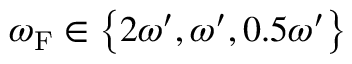Convert formula to latex. <formula><loc_0><loc_0><loc_500><loc_500>\omega _ { F } \in \left \{ 2 \omega ^ { \prime } , \omega ^ { \prime } , 0 . 5 \omega ^ { \prime } \right \}</formula> 